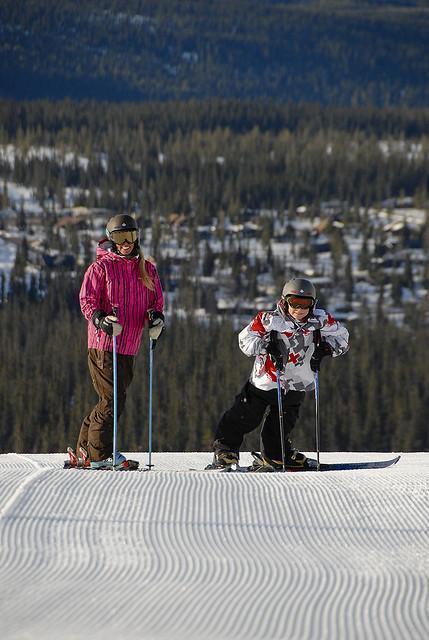What color are the vertical stripes on the left skier's jacket?
Make your selection and explain in format: 'Answer: answer
Rationale: rationale.'
Options: Blue, black, white, green. Answer: black.
Rationale: This appears to be the color when i checked at 150 percent zoom. 